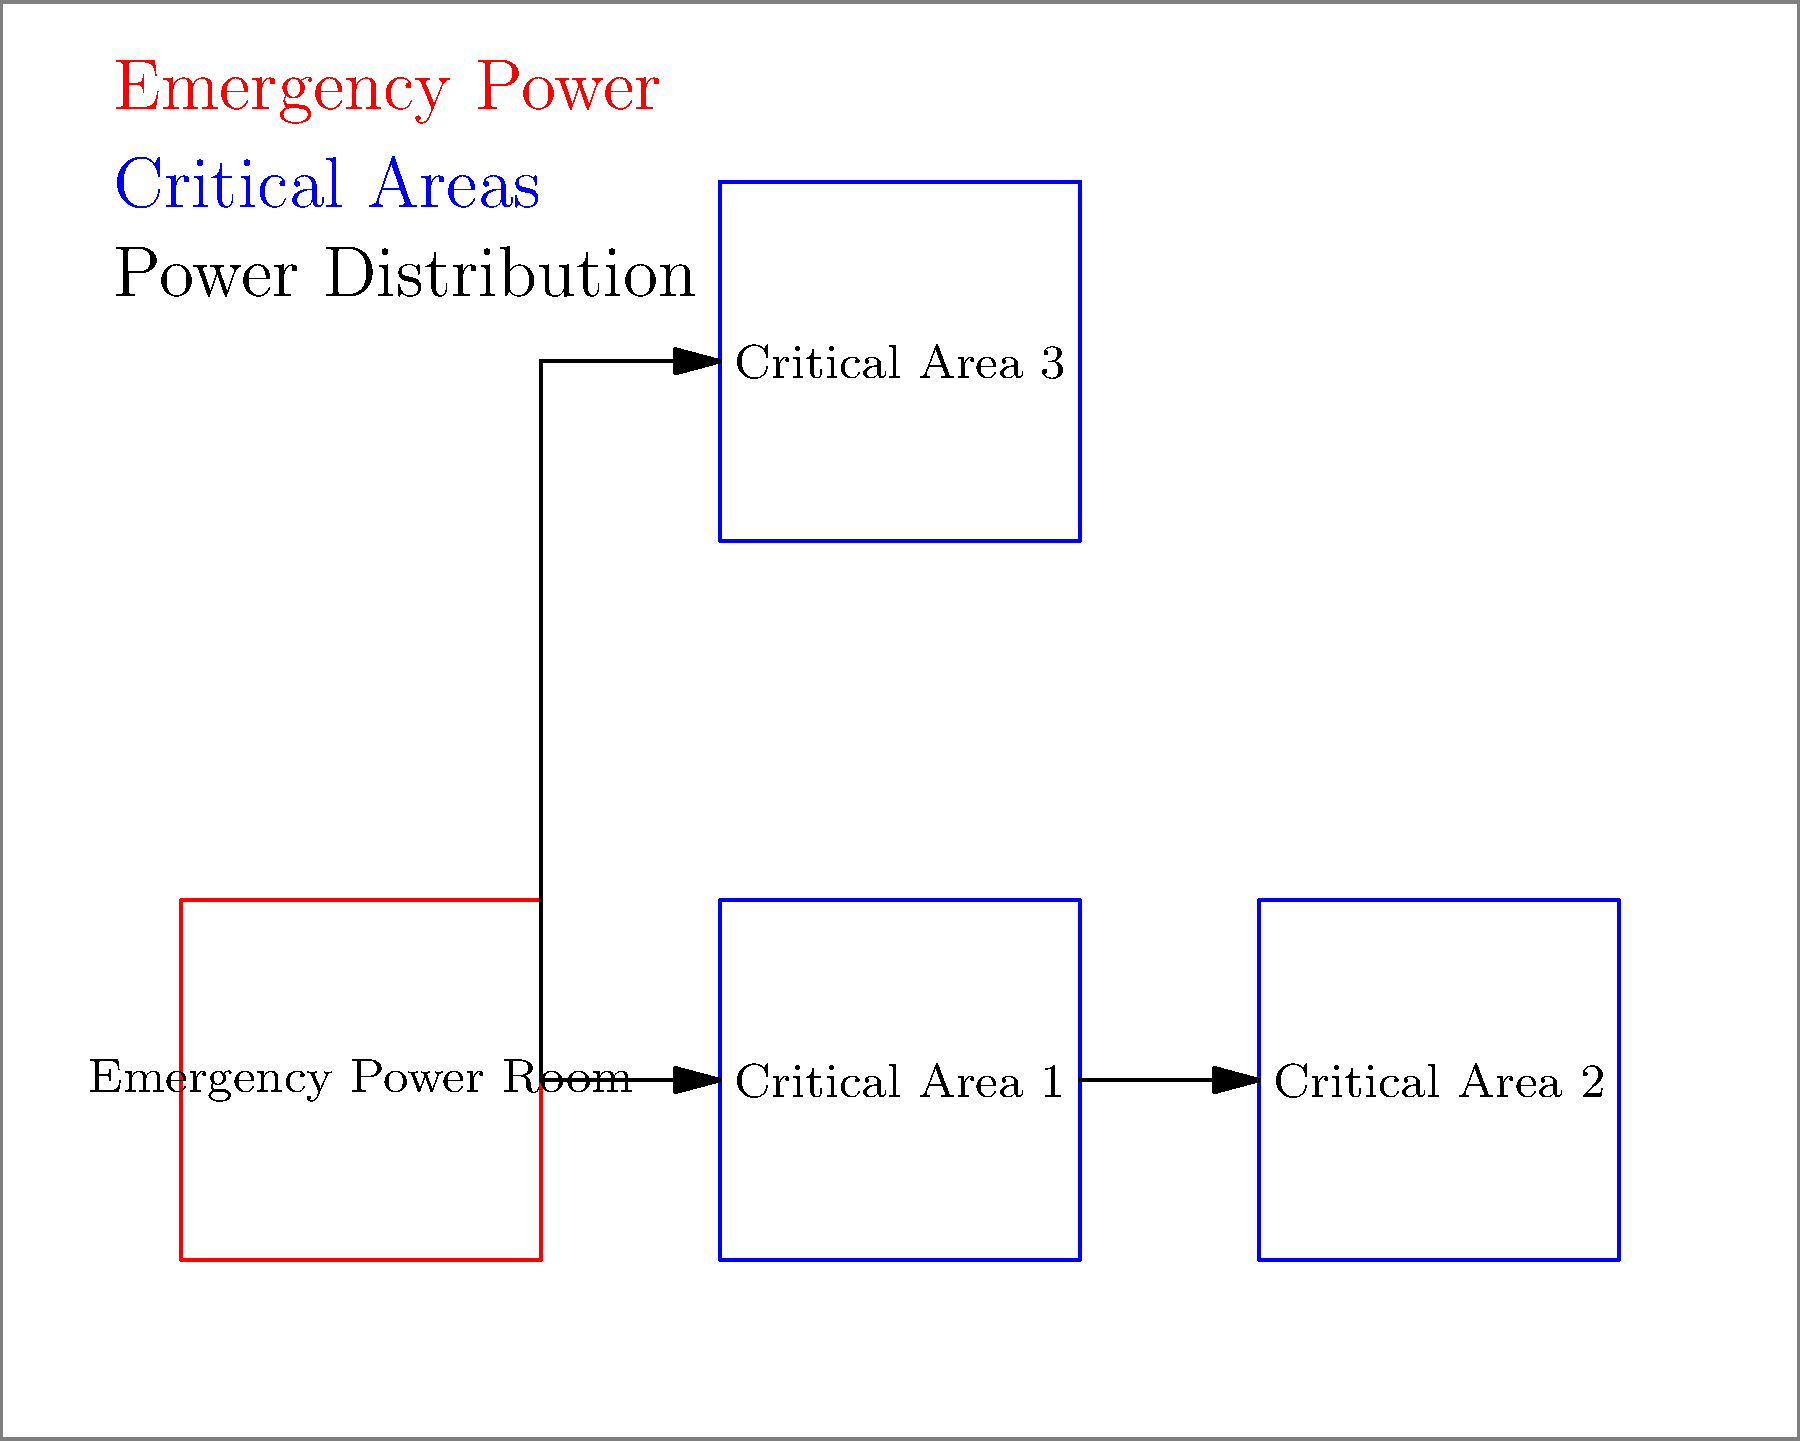Based on the schematic layout of a healthcare facility shown above, what is the primary consideration for the placement of the emergency power room, and how does it relate to the critical areas? To answer this question, let's analyze the schematic layout step-by-step:

1. Location of Emergency Power Room:
   The emergency power room is positioned in the lower-left corner of the facility.

2. Proximity to Critical Areas:
   The emergency power room is relatively close to Critical Areas 1 and 2, but farther from Critical Area 3.

3. Power Distribution:
   Power lines are shown connecting the emergency power room to all critical areas.

4. Accessibility:
   The emergency power room is placed near an outer wall, potentially allowing easier access for maintenance and fuel delivery.

5. Safety Considerations:
   Its location away from the center of the facility could reduce risks to patients and staff in case of equipment failure or fire.

6. Efficiency:
   The central location relative to Critical Areas 1 and 2 minimizes the length of power distribution lines, potentially reducing power loss and installation costs.

The primary consideration for the placement of the emergency power room is to balance proximity to critical areas with safety and accessibility. This placement allows for efficient power distribution to most critical areas while maintaining a degree of separation for safety and easy external access for maintenance and refueling.
Answer: Balance of proximity to critical areas, safety, and accessibility 